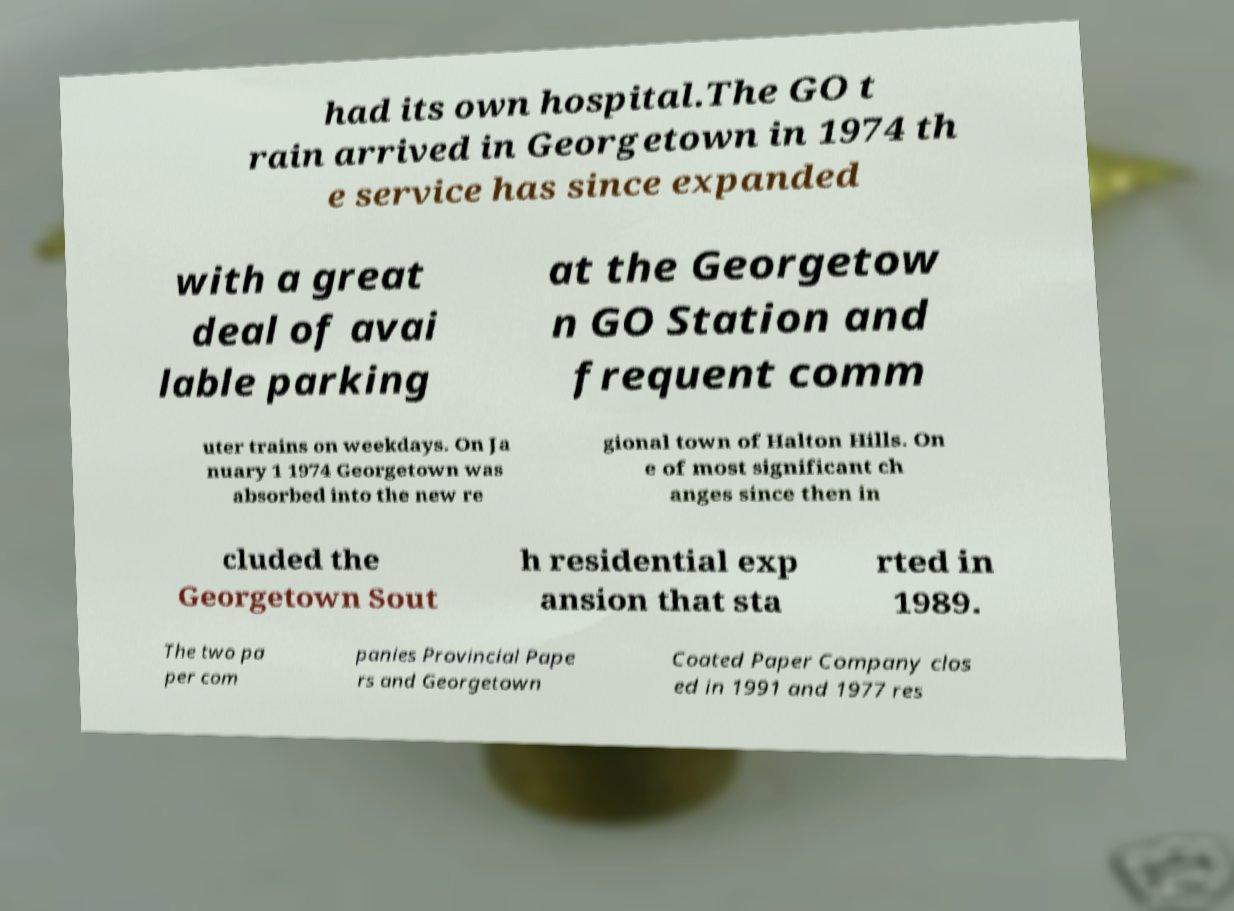What messages or text are displayed in this image? I need them in a readable, typed format. had its own hospital.The GO t rain arrived in Georgetown in 1974 th e service has since expanded with a great deal of avai lable parking at the Georgetow n GO Station and frequent comm uter trains on weekdays. On Ja nuary 1 1974 Georgetown was absorbed into the new re gional town of Halton Hills. On e of most significant ch anges since then in cluded the Georgetown Sout h residential exp ansion that sta rted in 1989. The two pa per com panies Provincial Pape rs and Georgetown Coated Paper Company clos ed in 1991 and 1977 res 